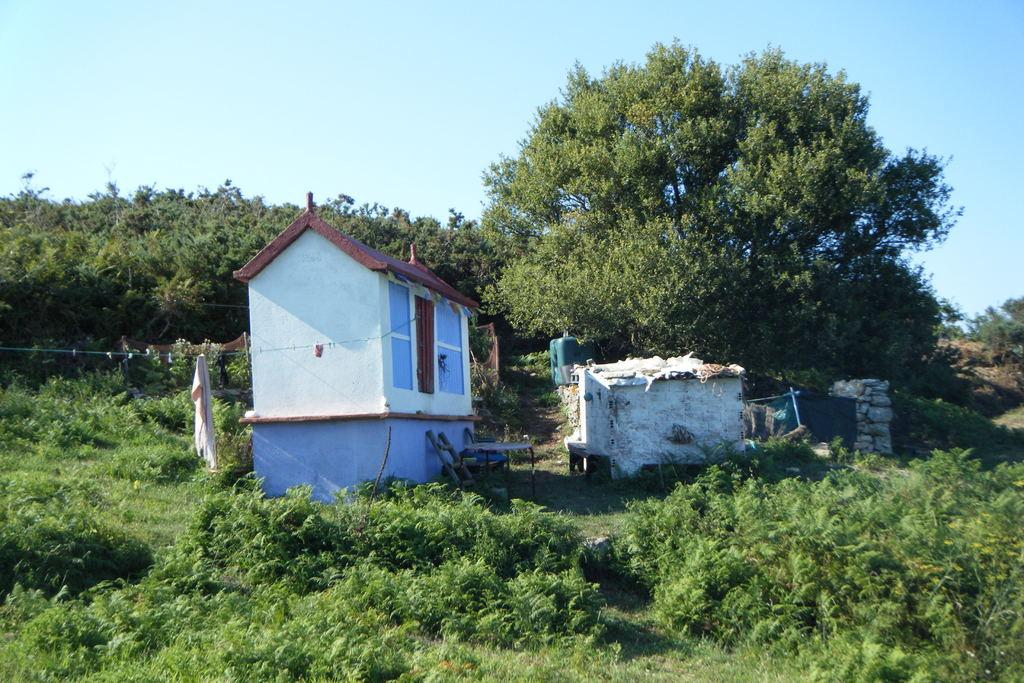What types of vegetation can be seen in the foreground of the image? There are plants and grass in the foreground of the image. What other objects or structures are present in the foreground of the image? There are houses and trees in the foreground of the image. What is the color of the sky in the image? The sky is blue and visible at the top of the image. Can you describe the setting of the image? The image may have been taken in a farm, as there are plants, grass, and trees present. Are there any bears visible in the image? No, there are no bears present in the image. Can you tell me how many family members are in the image? There is no reference to a family or any family members in the image. 